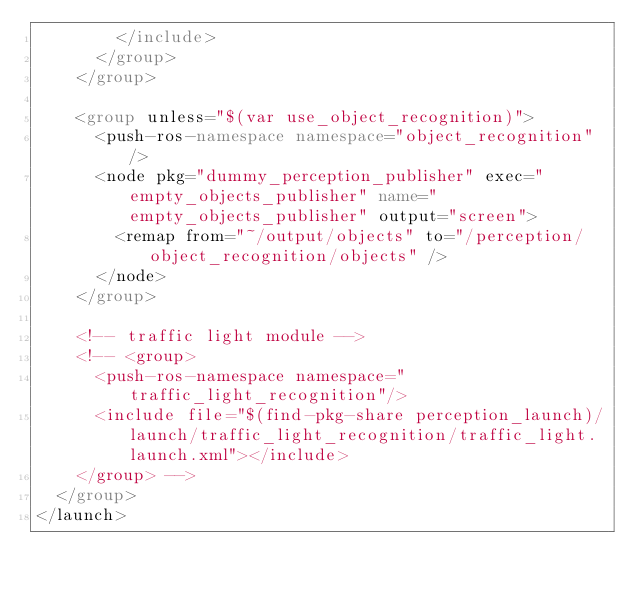<code> <loc_0><loc_0><loc_500><loc_500><_XML_>        </include>
      </group>
    </group>

    <group unless="$(var use_object_recognition)">
      <push-ros-namespace namespace="object_recognition"/>
      <node pkg="dummy_perception_publisher" exec="empty_objects_publisher" name="empty_objects_publisher" output="screen">
        <remap from="~/output/objects" to="/perception/object_recognition/objects" />
      </node>
    </group>

    <!-- traffic light module -->
    <!-- <group>
      <push-ros-namespace namespace="traffic_light_recognition"/>
      <include file="$(find-pkg-share perception_launch)/launch/traffic_light_recognition/traffic_light.launch.xml"></include>
    </group> -->
  </group>
</launch>
</code> 